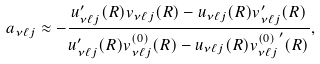<formula> <loc_0><loc_0><loc_500><loc_500>a _ { \nu { \ell } j } \approx - \frac { u _ { \nu { \ell } j } ^ { \prime } ( R ) v _ { \nu { \ell } j } ( R ) - u _ { \nu { \ell } j } ( R ) v _ { \nu { \ell } j } ^ { \prime } ( R ) } { u _ { \nu { \ell } j } ^ { \prime } ( R ) v _ { \nu { \ell } j } ^ { ( 0 ) } ( R ) - u _ { \nu { \ell } j } ( R ) { v _ { \nu { \ell } j } ^ { ( 0 ) } } ^ { \prime } ( R ) } ,</formula> 